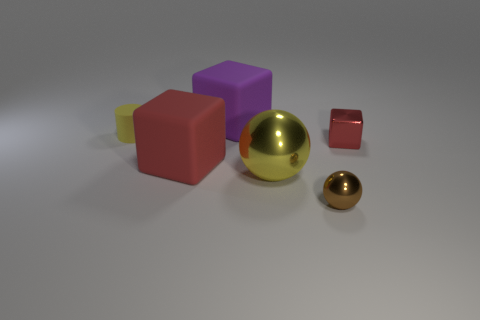Add 2 large yellow spheres. How many objects exist? 8 Subtract all cylinders. How many objects are left? 5 Add 5 shiny blocks. How many shiny blocks exist? 6 Subtract 1 red blocks. How many objects are left? 5 Subtract all big yellow balls. Subtract all red rubber things. How many objects are left? 4 Add 4 red metallic cubes. How many red metallic cubes are left? 5 